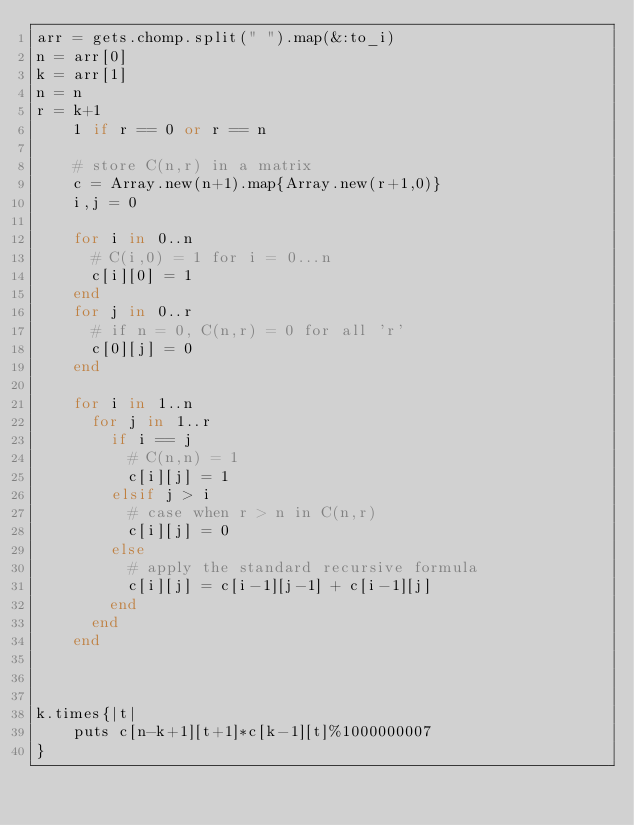<code> <loc_0><loc_0><loc_500><loc_500><_Ruby_>arr = gets.chomp.split(" ").map(&:to_i)
n = arr[0]
k = arr[1]
n = n
r = k+1
    1 if r == 0 or r == n
  
    # store C(n,r) in a matrix
    c = Array.new(n+1).map{Array.new(r+1,0)}
    i,j = 0
  
    for i in 0..n
      # C(i,0) = 1 for i = 0...n
      c[i][0] = 1
    end
    for j in 0..r
      # if n = 0, C(n,r) = 0 for all 'r'
      c[0][j] = 0
    end
  
    for i in 1..n
      for j in 1..r
        if i == j
          # C(n,n) = 1
          c[i][j] = 1
        elsif j > i
          # case when r > n in C(n,r)
          c[i][j] = 0
        else
          # apply the standard recursive formula
          c[i][j] = c[i-1][j-1] + c[i-1][j]
        end
      end
    end
  


k.times{|t|
    puts c[n-k+1][t+1]*c[k-1][t]%1000000007
}</code> 